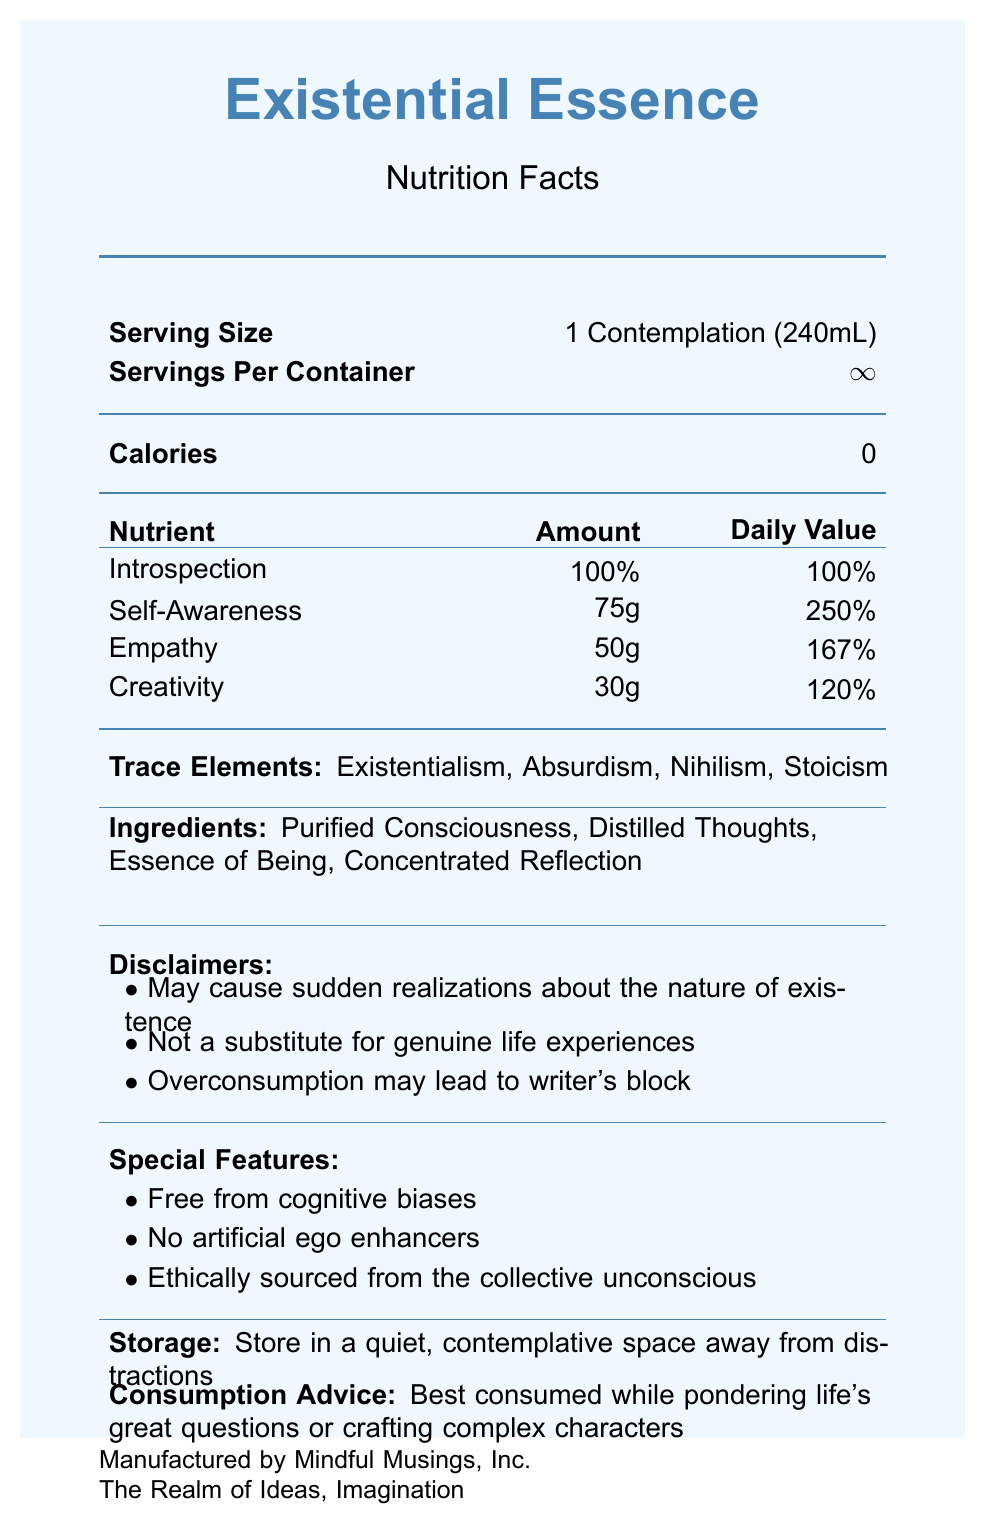what is the serving size of Existential Essence? The serving size is specified in the document under the "Serving Size" section.
Answer: 1 Contemplation (240mL) how many calories are there per serving? The document states that there are 0 calories per serving.
Answer: 0 what are the ingredients in Existential Essence? The ingredients are listed in the document under the "Ingredients" section.
Answer: Purified Consciousness, Distilled Thoughts, Essence of Being, Concentrated Reflection what percentage of Introspection is present in Existential Essence? It is indicated that there is 100% Introspection in the document.
Answer: 100% what are the trace elements mentioned in the document? The trace elements are listed under the "Trace Elements" section in the document.
Answer: Existentialism, Absurdism, Nihilism, Stoicism which of the following is a warning mentioned in the disclaimers? A. May cause sudden realizations about the nature of existence B. Contains artificial ego enhancers C. Not safe for consumption The correct option is A. The other options are not mentioned in the disclaimers.
Answer: A which of the following daily value percentages is correct for Empathy? 1. 120% 2. 250% 3. 167% The daily value percentage for Empathy is 167% as listed in the nutrients section.
Answer: 3. 167% is the Existential Essence product free from cognitive biases? The document lists "Free from cognitive biases" under the special features section.
Answer: Yes summarize the main idea of the document. This summary captures the essence of the various sections mentioned, including nutrients, elements, disclaimers, and additional advice.
Answer: The document provides the nutrition facts for the product named Existential Essence, presenting abstract concepts as nutrients, including Introspection, Self-Awareness, Empathy, and Creativity. It also lists ingredients, trace elements, special features, disclaimers, storage instructions, and consumption advice. how should Existential Essence be stored? The document provides storage instructions under the "Storage" section.
Answer: Store in a quiet, contemplative space away from distractions who manufactures Existential Essence? The manufacturer information is listed at the bottom of the document.
Answer: Mindful Musings, Inc. what is the daily value percentage of Self-Awareness? According to the document, the daily value percentage for Self-Awareness is 250%.
Answer: 250% what kind of realizations might the consumption of Existential Essence cause? This is one of the disclaimers mentioned in the document.
Answer: Sudden realizations about the nature of existence how many servings are in each container of Existential Essence? The servings per container are listed as infinite (\(\infty\)) in the document.
Answer: ∞ what does the warning about overconsumption indicate? One of the disclaimers warns specifically about writer's block due to overconsumption.
Answer: Overconsumption may lead to writer's block can Existential Essence be used as a substitute for genuine life experiences? The document explicitly states, "Not a substitute for genuine life experiences."
Answer: No what does the document's design aim to evoke? The design aspects of evoking specific feelings or aims are not discussed or described in the document.
Answer: Cannot be determined 